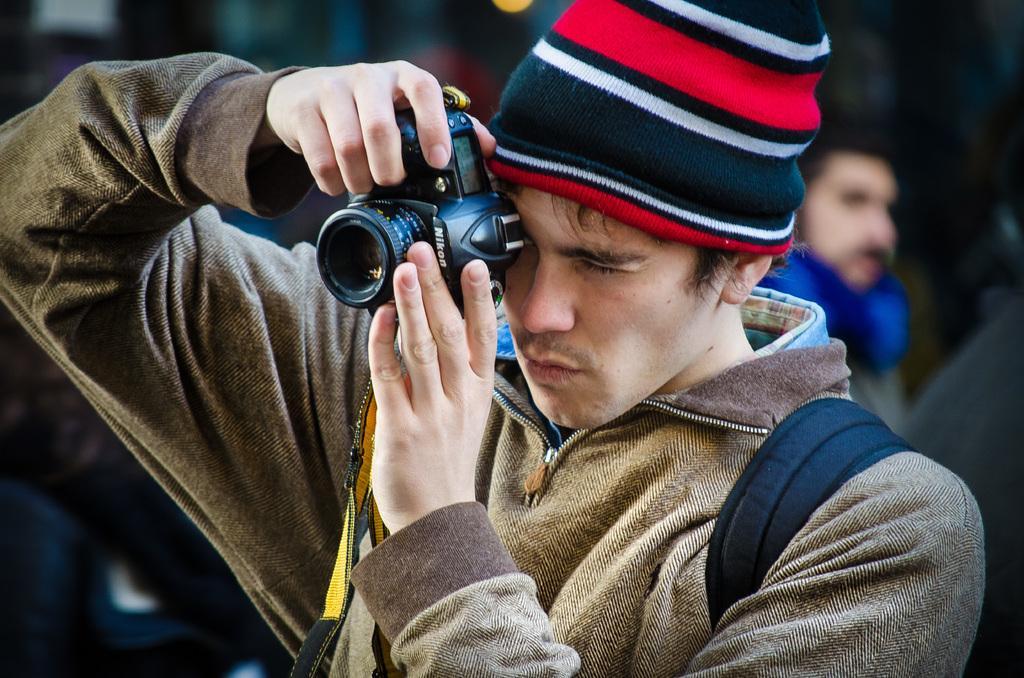Can you describe this image briefly? In this image In the middle there is a man he wear jacket, bag, shirt and cap he is holding a camera. In the background there is a man. 